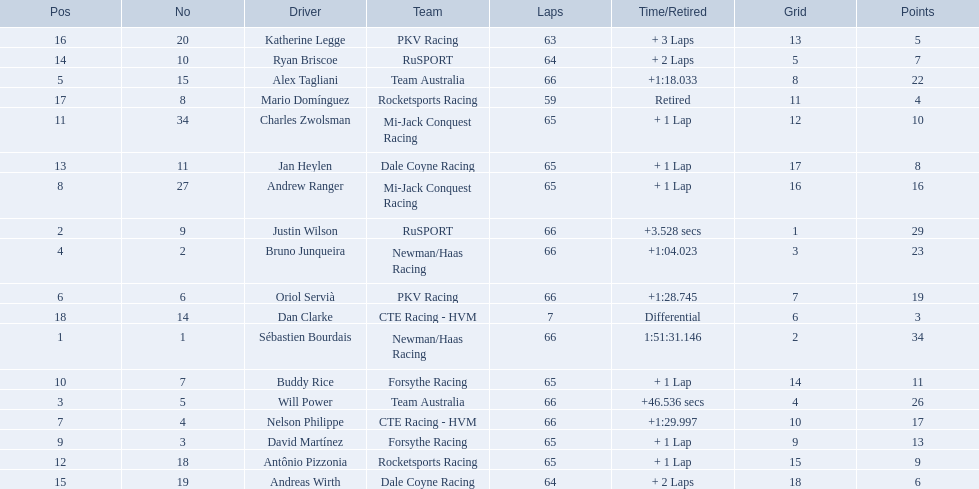Who are all of the 2006 gran premio telmex drivers? Sébastien Bourdais, Justin Wilson, Will Power, Bruno Junqueira, Alex Tagliani, Oriol Servià, Nelson Philippe, Andrew Ranger, David Martínez, Buddy Rice, Charles Zwolsman, Antônio Pizzonia, Jan Heylen, Ryan Briscoe, Andreas Wirth, Katherine Legge, Mario Domínguez, Dan Clarke. How many laps did they finish? 66, 66, 66, 66, 66, 66, 66, 65, 65, 65, 65, 65, 65, 64, 64, 63, 59, 7. What about just oriol servia and katherine legge? 66, 63. And which of those two drivers finished more laps? Oriol Servià. 